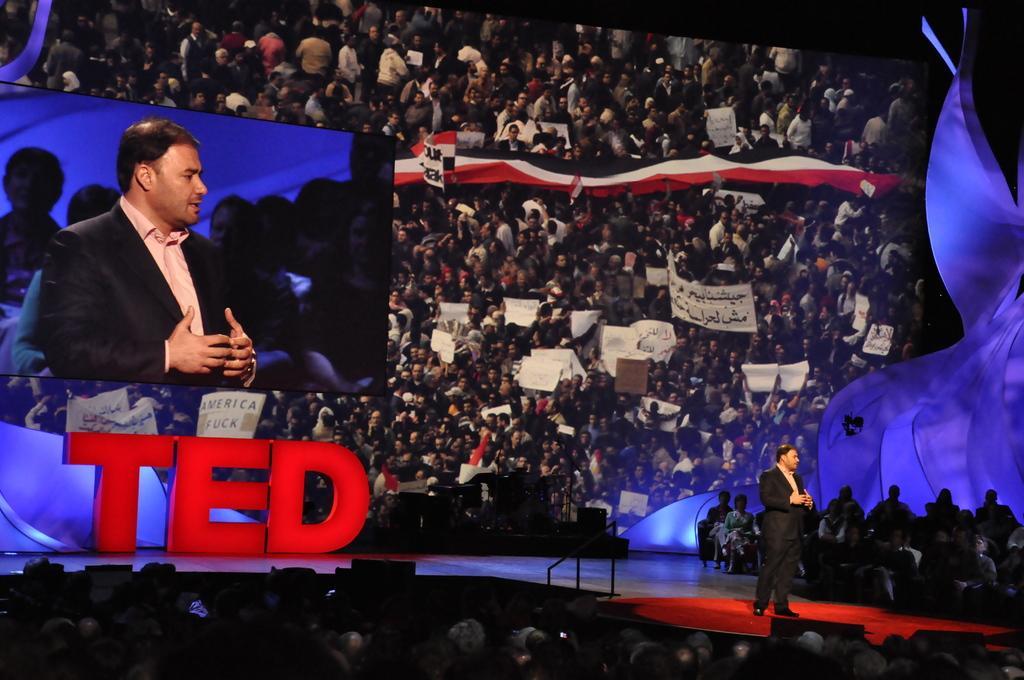Can you describe this image briefly? On the right side of the image we can see a man standing. At the bottom there is crowd. On the left there is a screen. In the background there is a board. 